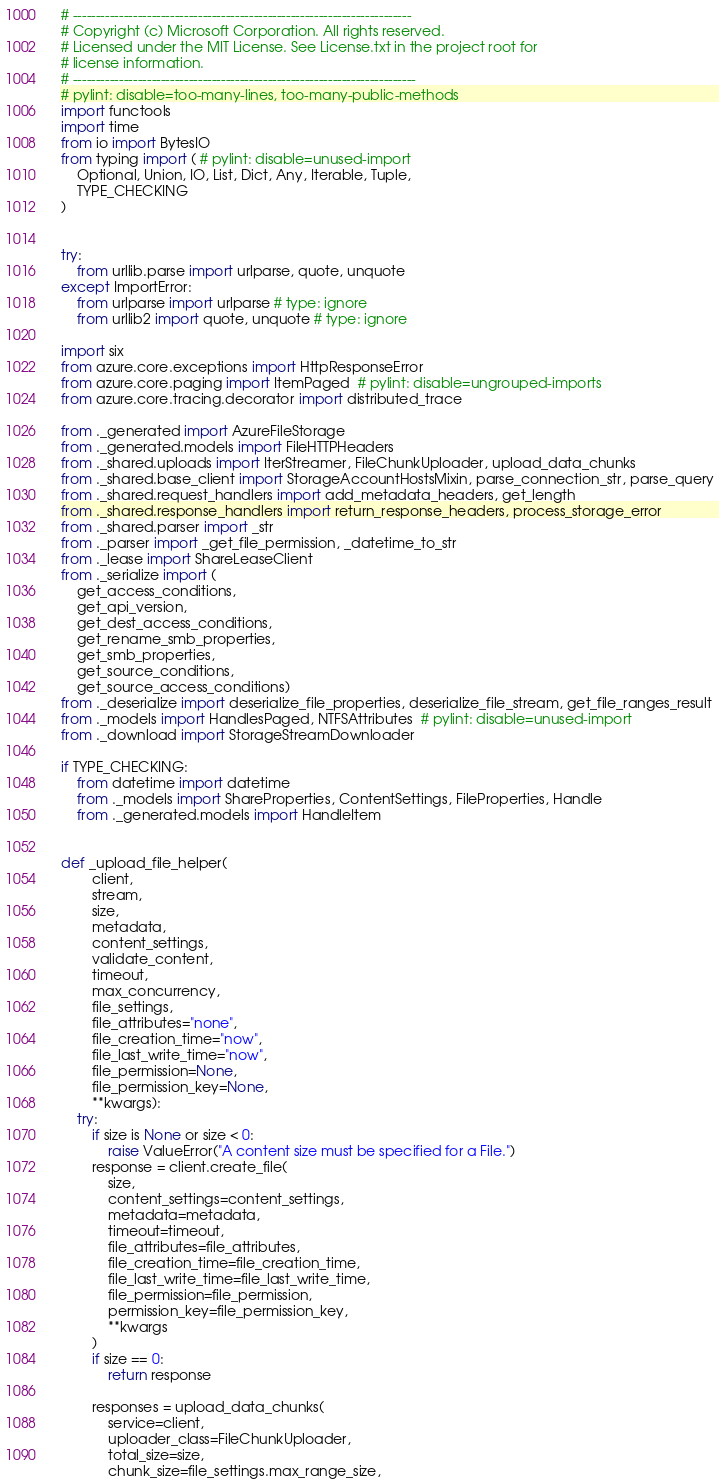<code> <loc_0><loc_0><loc_500><loc_500><_Python_># -------------------------------------------------------------------------
# Copyright (c) Microsoft Corporation. All rights reserved.
# Licensed under the MIT License. See License.txt in the project root for
# license information.
# --------------------------------------------------------------------------
# pylint: disable=too-many-lines, too-many-public-methods
import functools
import time
from io import BytesIO
from typing import ( # pylint: disable=unused-import
    Optional, Union, IO, List, Dict, Any, Iterable, Tuple,
    TYPE_CHECKING
)


try:
    from urllib.parse import urlparse, quote, unquote
except ImportError:
    from urlparse import urlparse # type: ignore
    from urllib2 import quote, unquote # type: ignore

import six
from azure.core.exceptions import HttpResponseError
from azure.core.paging import ItemPaged  # pylint: disable=ungrouped-imports
from azure.core.tracing.decorator import distributed_trace

from ._generated import AzureFileStorage
from ._generated.models import FileHTTPHeaders
from ._shared.uploads import IterStreamer, FileChunkUploader, upload_data_chunks
from ._shared.base_client import StorageAccountHostsMixin, parse_connection_str, parse_query
from ._shared.request_handlers import add_metadata_headers, get_length
from ._shared.response_handlers import return_response_headers, process_storage_error
from ._shared.parser import _str
from ._parser import _get_file_permission, _datetime_to_str
from ._lease import ShareLeaseClient
from ._serialize import (
    get_access_conditions,
    get_api_version,
    get_dest_access_conditions,
    get_rename_smb_properties,
    get_smb_properties,
    get_source_conditions,
    get_source_access_conditions)
from ._deserialize import deserialize_file_properties, deserialize_file_stream, get_file_ranges_result
from ._models import HandlesPaged, NTFSAttributes  # pylint: disable=unused-import
from ._download import StorageStreamDownloader

if TYPE_CHECKING:
    from datetime import datetime
    from ._models import ShareProperties, ContentSettings, FileProperties, Handle
    from ._generated.models import HandleItem


def _upload_file_helper(
        client,
        stream,
        size,
        metadata,
        content_settings,
        validate_content,
        timeout,
        max_concurrency,
        file_settings,
        file_attributes="none",
        file_creation_time="now",
        file_last_write_time="now",
        file_permission=None,
        file_permission_key=None,
        **kwargs):
    try:
        if size is None or size < 0:
            raise ValueError("A content size must be specified for a File.")
        response = client.create_file(
            size,
            content_settings=content_settings,
            metadata=metadata,
            timeout=timeout,
            file_attributes=file_attributes,
            file_creation_time=file_creation_time,
            file_last_write_time=file_last_write_time,
            file_permission=file_permission,
            permission_key=file_permission_key,
            **kwargs
        )
        if size == 0:
            return response

        responses = upload_data_chunks(
            service=client,
            uploader_class=FileChunkUploader,
            total_size=size,
            chunk_size=file_settings.max_range_size,</code> 